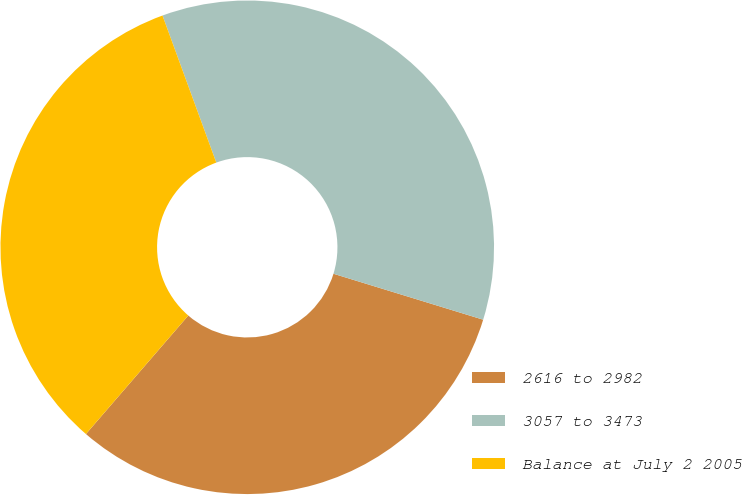Convert chart to OTSL. <chart><loc_0><loc_0><loc_500><loc_500><pie_chart><fcel>2616 to 2982<fcel>3057 to 3473<fcel>Balance at July 2 2005<nl><fcel>31.6%<fcel>35.32%<fcel>33.08%<nl></chart> 